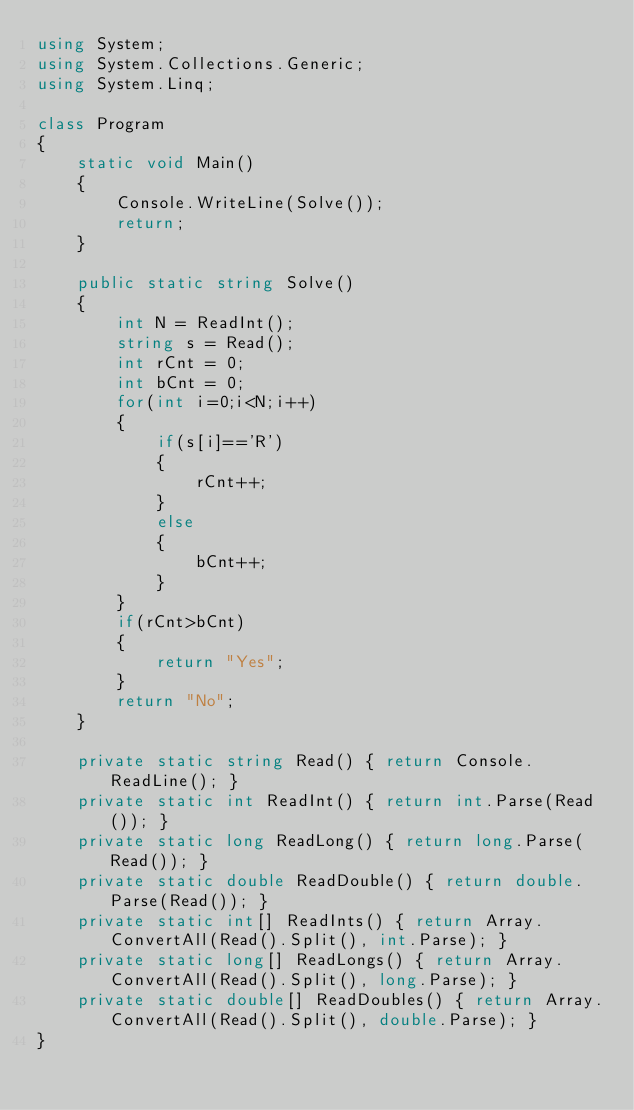<code> <loc_0><loc_0><loc_500><loc_500><_C#_>using System;
using System.Collections.Generic;
using System.Linq;

class Program
{
    static void Main()
    {
        Console.WriteLine(Solve());
        return;
    }

    public static string Solve()
    {
        int N = ReadInt();
        string s = Read();
        int rCnt = 0;
        int bCnt = 0;
        for(int i=0;i<N;i++)
        {
            if(s[i]=='R')
            {
                rCnt++;
            }
            else
            {
                bCnt++;
            }
        }
        if(rCnt>bCnt)
        {
            return "Yes";
        }
        return "No";
    }

    private static string Read() { return Console.ReadLine(); }
    private static int ReadInt() { return int.Parse(Read()); }
    private static long ReadLong() { return long.Parse(Read()); }
    private static double ReadDouble() { return double.Parse(Read()); }
    private static int[] ReadInts() { return Array.ConvertAll(Read().Split(), int.Parse); }
    private static long[] ReadLongs() { return Array.ConvertAll(Read().Split(), long.Parse); }
    private static double[] ReadDoubles() { return Array.ConvertAll(Read().Split(), double.Parse); }
}
</code> 